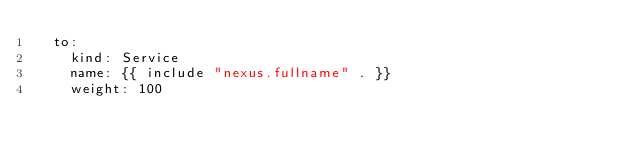Convert code to text. <code><loc_0><loc_0><loc_500><loc_500><_YAML_>  to:
    kind: Service
    name: {{ include "nexus.fullname" . }}
    weight: 100
</code> 